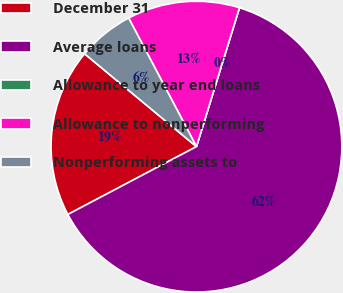<chart> <loc_0><loc_0><loc_500><loc_500><pie_chart><fcel>December 31<fcel>Average loans<fcel>Allowance to year end loans<fcel>Allowance to nonperforming<fcel>Nonperforming assets to<nl><fcel>18.75%<fcel>62.49%<fcel>0.0%<fcel>12.5%<fcel>6.25%<nl></chart> 